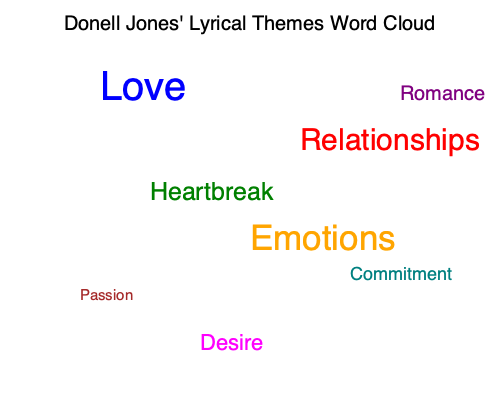Based on the word cloud visualization of Donell Jones' lyrical themes, which theme appears to be the most prominent, and how does this reflect his overall artistic focus throughout his discography? To answer this question, we need to analyze the word cloud visualization and interpret its representation of Donell Jones' lyrical themes:

1. Identify the most prominent theme:
   - The largest word in the cloud is "Love," indicating it's the most frequent or significant theme in Jones' lyrics.
   - Its size and central position emphasize its importance.

2. Examine supporting themes:
   - "Relationships" and "Emotions" are also prominent, suggesting they're closely related to the main theme of love.
   - "Heartbreak," "Romance," and "Desire" further support the love-centric focus.

3. Consider the overall composition:
   - All words in the cloud relate to romantic relationships and emotional experiences.
   - This consistency reinforces the centrality of love in Jones' work.

4. Reflect on Donell Jones' artistic focus:
   - The prevalence of love-related themes suggests Jones primarily explores various aspects of romantic relationships in his music.
   - The diversity of love-related words (e.g., heartbreak, passion, commitment) indicates he examines love from multiple angles and stages.

5. Connect to his discography:
   - This thematic focus aligns with Jones' reputation as an R&B artist, a genre often associated with love songs and emotional storytelling.
   - The visualization suggests that throughout his career, Jones has consistently centered his lyrical content on love and its various facets.

In conclusion, the word cloud reveals that love is the most prominent theme in Donell Jones' lyrics, reflecting an artistic focus on exploring the complexities of romantic relationships and emotional experiences throughout his discography.
Answer: Love; consistent focus on romantic relationships and emotions 